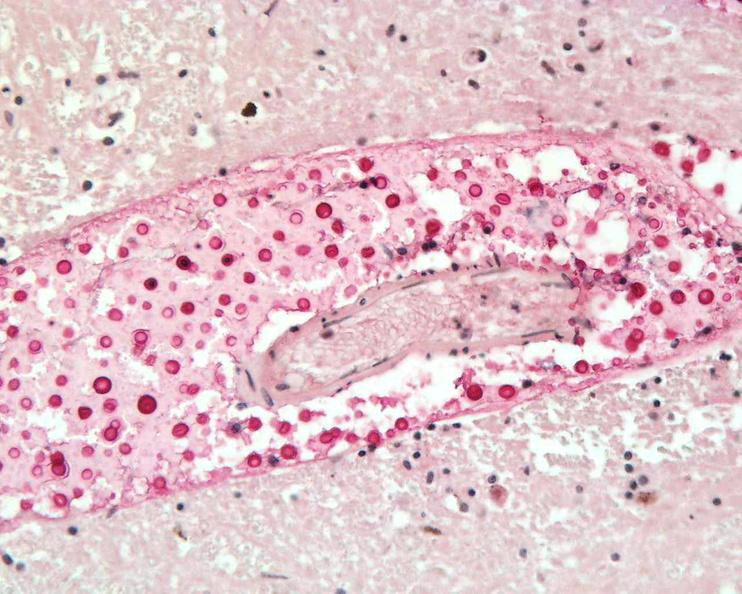s nervous present?
Answer the question using a single word or phrase. Yes 